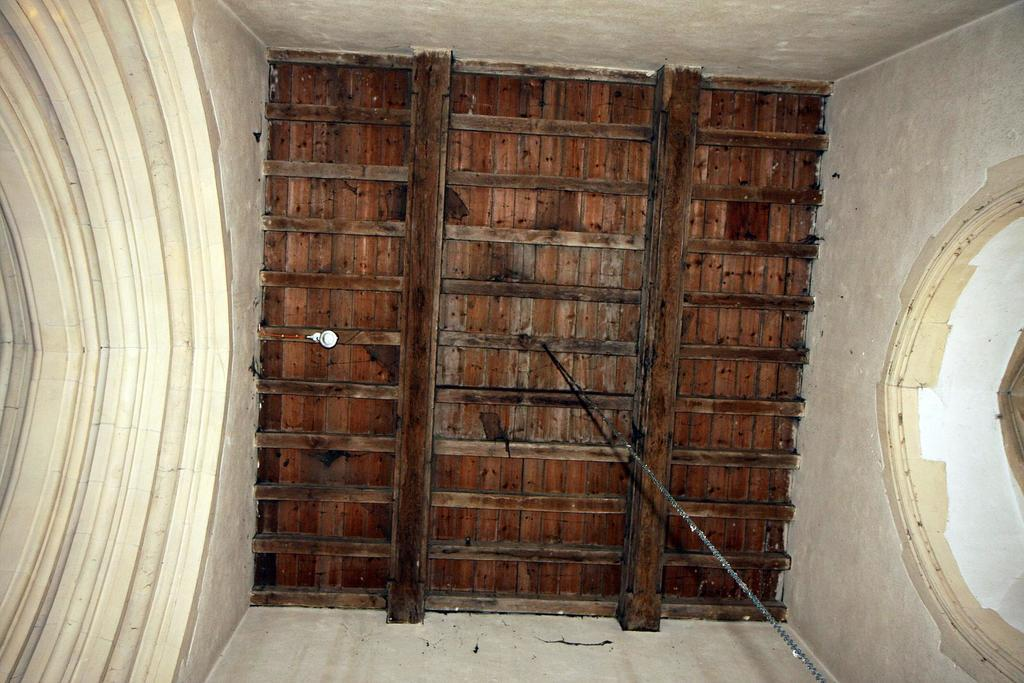What type of door is visible in the image? There is a wooden door in the image. Are there any additional features on the door? Yes, there is a round-shaped window on the left side of the door. What is connected to the bottom of the door? There is a rope connected to the bottom of the door. What is the wooden door saying with its mouth in the image? There is no mouth on the wooden door, as it is an inanimate object and cannot speak. 